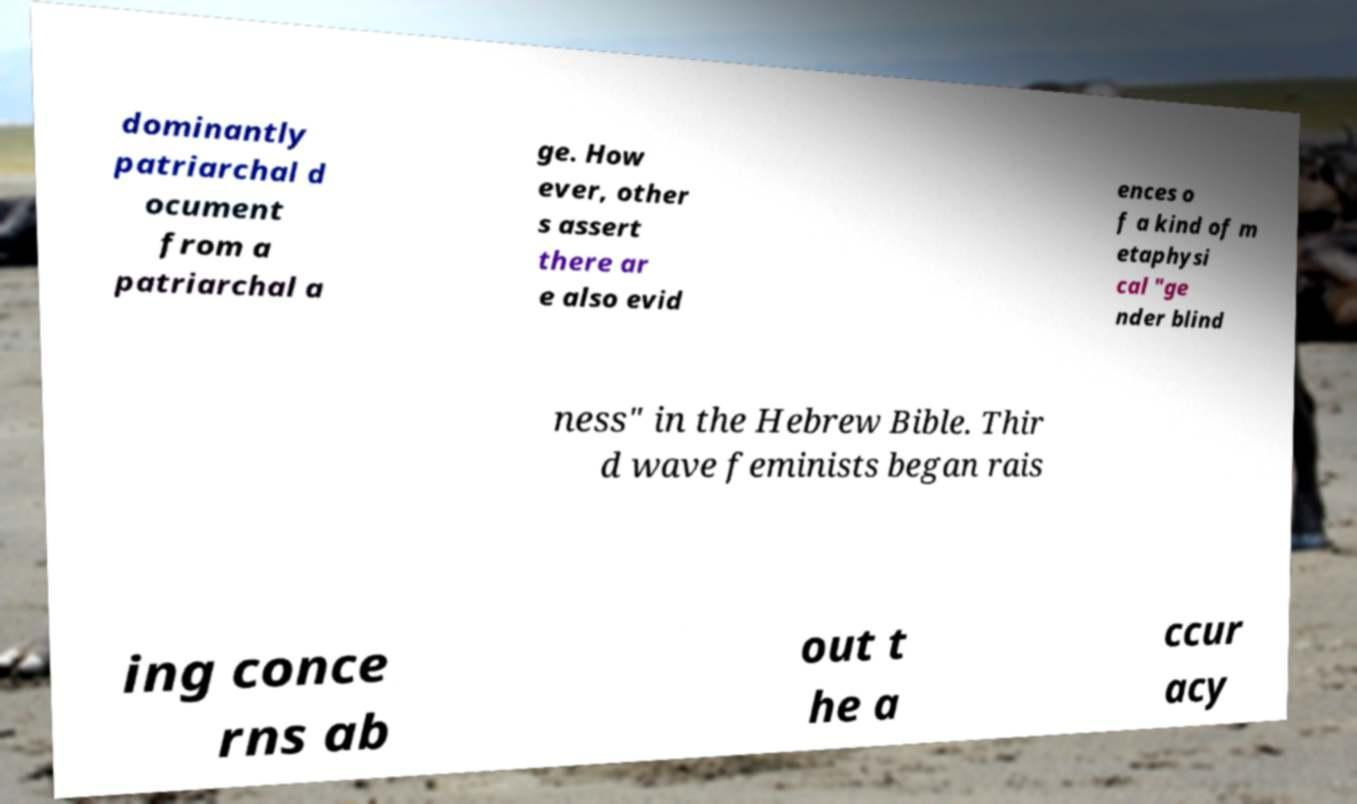Please read and relay the text visible in this image. What does it say? dominantly patriarchal d ocument from a patriarchal a ge. How ever, other s assert there ar e also evid ences o f a kind of m etaphysi cal "ge nder blind ness" in the Hebrew Bible. Thir d wave feminists began rais ing conce rns ab out t he a ccur acy 